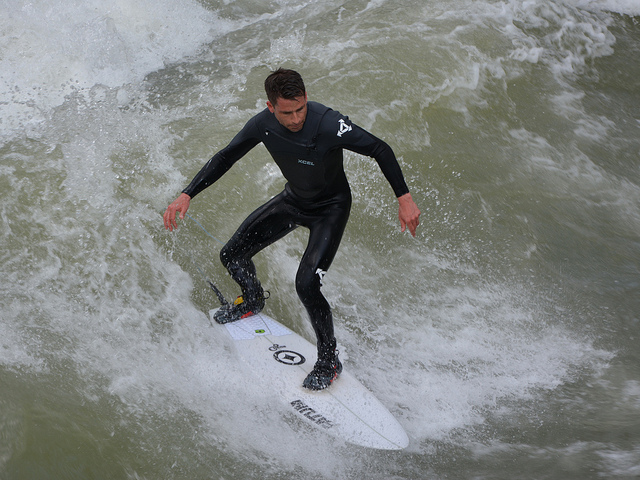<image>What is the logo on the man's shirt? It is ambiguous what the logo on the man's shirt is. It could be 'ray ban', 'triangle', 'umbra', 'warning', 'adidas', 'billabong', 'under armour', or 'element'. What is the logo on the man's shirt? I am not sure what the logo is on the man's shirt. It can be any of ['ray ban', 'triangle', 'umbra', 'warning', 'adidas', 'billabong', 'none', 'unknown', 'under armour', 'element']. 